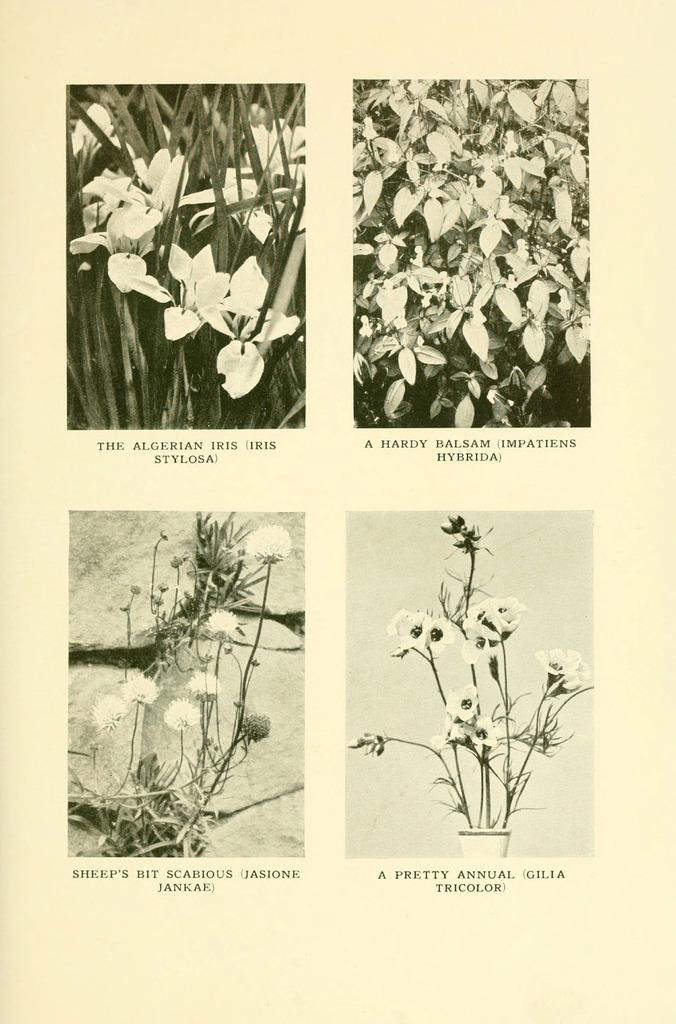What object can be seen in the image that holds plants? There is a flower pot in the image. What type of flowers are in the flower pot? White flowers are present in the image. What other part of the plants can be seen in the image? Green leaves are visible in the image. What type of lettuce is growing in the image? There is no lettuce present in the image; it features a flower pot with white flowers and green leaves. 